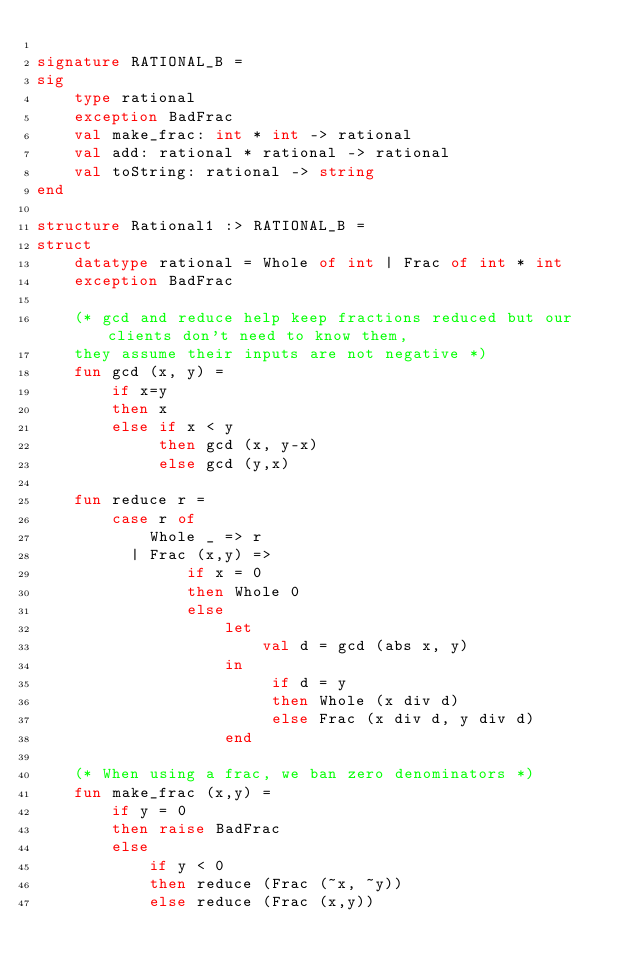Convert code to text. <code><loc_0><loc_0><loc_500><loc_500><_SML_>
signature RATIONAL_B =
sig
    type rational
    exception BadFrac
    val make_frac: int * int -> rational
    val add: rational * rational -> rational
    val toString: rational -> string
end

structure Rational1 :> RATIONAL_B =
struct
    datatype rational = Whole of int | Frac of int * int
    exception BadFrac

    (* gcd and reduce help keep fractions reduced but our clients don't need to know them, 
    they assume their inputs are not negative *)
    fun gcd (x, y) =
        if x=y
        then x
        else if x < y
             then gcd (x, y-x)
             else gcd (y,x)

    fun reduce r =
        case r of
            Whole _ => r
          | Frac (x,y) => 
                if x = 0
                then Whole 0
                else 
                    let 
                        val d = gcd (abs x, y)
                    in
                         if d = y
                         then Whole (x div d)
                         else Frac (x div d, y div d)
                    end

    (* When using a frac, we ban zero denominators *)
    fun make_frac (x,y) =
        if y = 0
        then raise BadFrac
        else 
            if y < 0
            then reduce (Frac (~x, ~y))
            else reduce (Frac (x,y))
</code> 